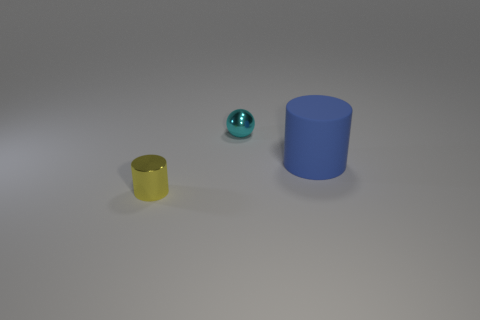Add 1 tiny yellow things. How many objects exist? 4 Subtract all blue cylinders. How many cylinders are left? 1 Subtract all balls. How many objects are left? 2 Subtract all tiny objects. Subtract all yellow things. How many objects are left? 0 Add 2 tiny cylinders. How many tiny cylinders are left? 3 Add 1 small yellow objects. How many small yellow objects exist? 2 Subtract 0 brown spheres. How many objects are left? 3 Subtract 1 balls. How many balls are left? 0 Subtract all brown cylinders. Subtract all gray balls. How many cylinders are left? 2 Subtract all cyan spheres. How many blue cylinders are left? 1 